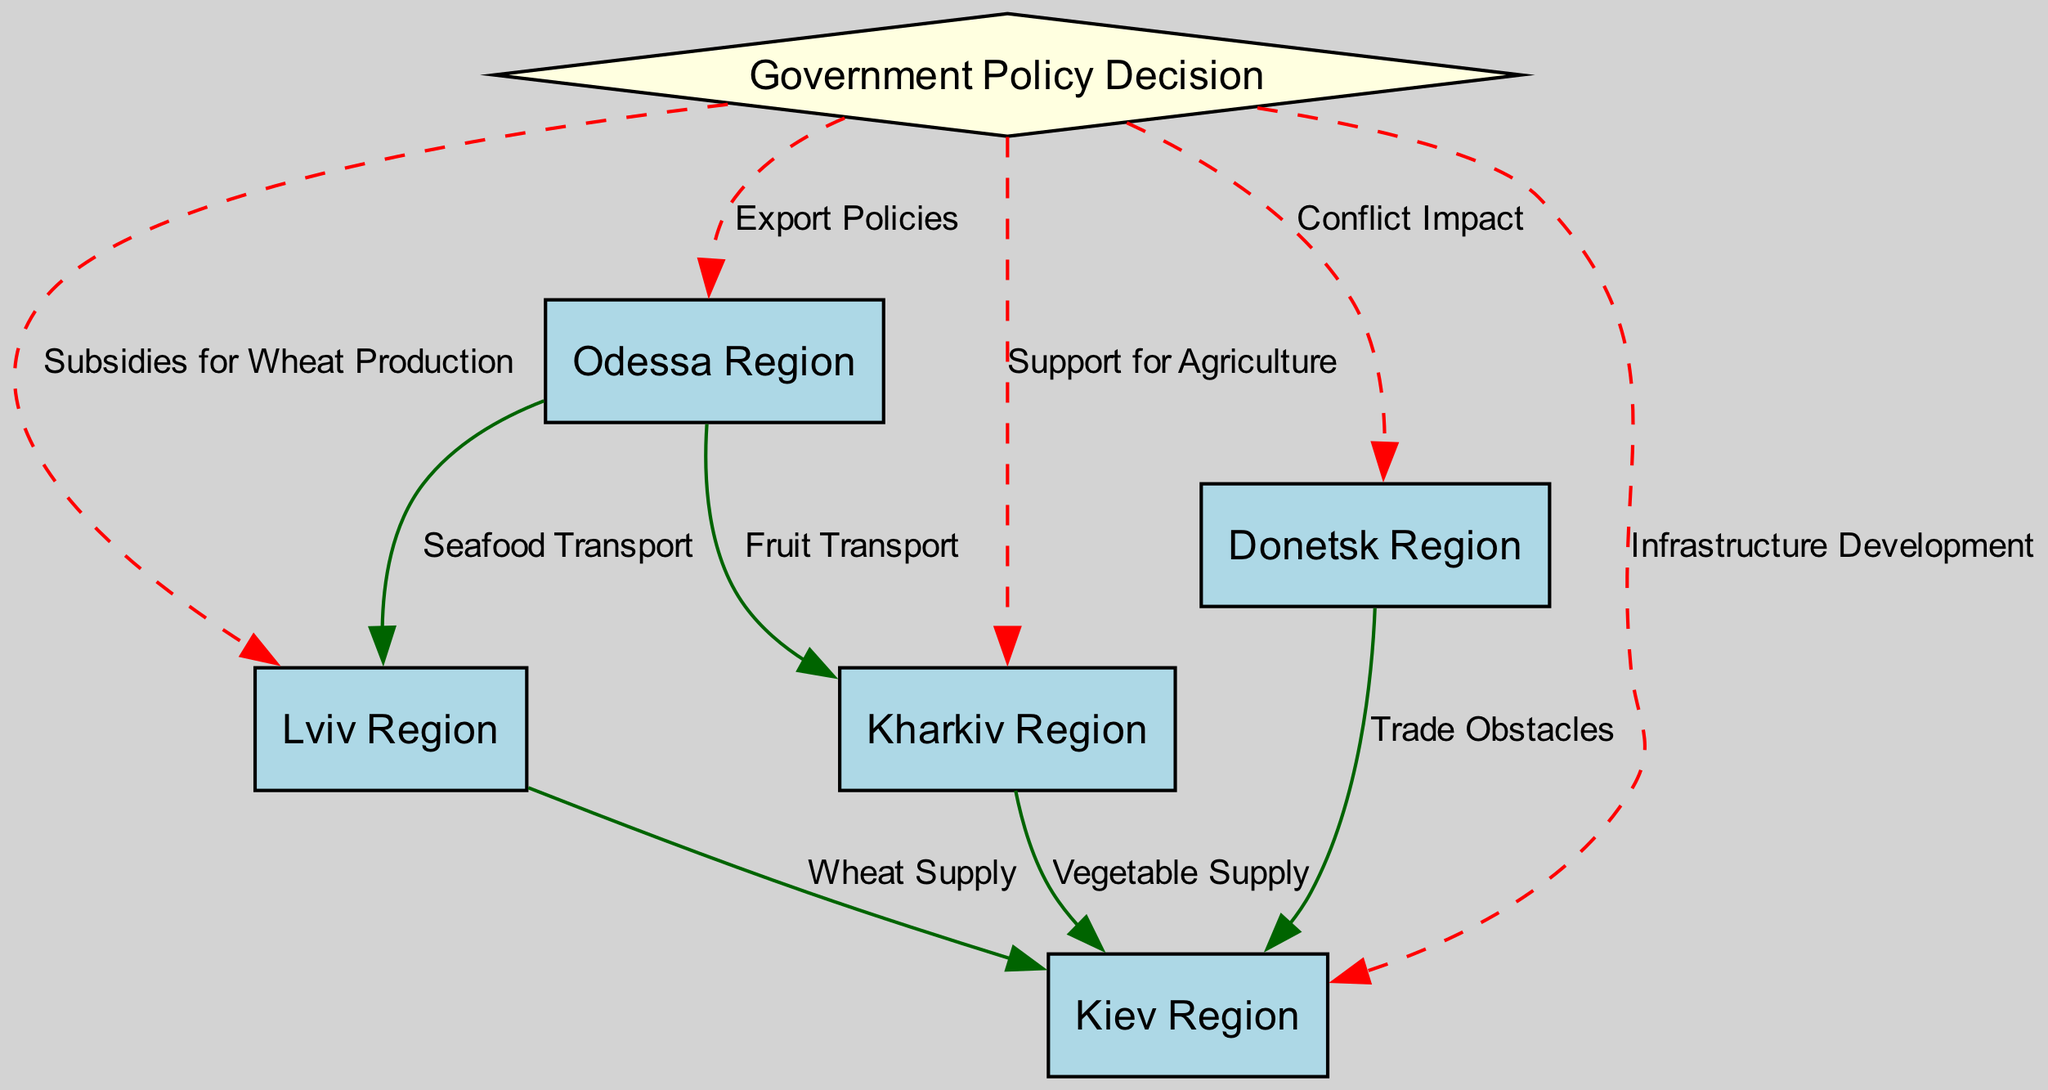What is the source of support for the Kharkiv Region in the diagram? The diagram indicates that the Kharkiv Region receives support through a direct policy labeled "Support for Agriculture," stemming from the Government Policy Decision node.
Answer: Support for Agriculture How many regions are directly linked to the Government Policy Decision? By analyzing the diagram, we observe that there are five edges leading from the Government Policy Decision to different regions (Lviv, Kiev, Odessa, Kharkiv, and Donetsk), thus confirming that five regions are directly linked.
Answer: 5 What type of transport is associated with the connection between Odessa and Lviv? The edge connecting Odessa to Lviv is labeled "Seafood Transport," indicating the specific type of transport involved in this relationship.
Answer: Seafood Transport Which region experiences trade obstacles affecting its supply routes? The diagram shows that the Donetsk Region faces trade obstacles as indicated by the edge labeled "Trade Obstacles" going to the Kiev Region, which influences its food supply dynamics.
Answer: Donetsk Region What relationship exists between the Kharkiv Region and Kiev in terms of food supply? The relationship is established through an edge labeled "Vegetable Supply," which indicates that Kharkiv region supplies vegetables to the Kiev region.
Answer: Vegetable Supply Which government decision primarily influences wheat production in relation to the Lviv Region? The Government Policy Decision impacts the Lviv Region specifically through the edge labeled "Subsidies for Wheat Production," indicating a financial influence aiming to boost wheat production.
Answer: Subsidies for Wheat Production List the two transportation links between Odessa and other regions. The diagram presents two transportation links: "Seafood Transport" from Odessa to Lviv and "Fruit Transport" from Odessa to Kharkiv, illustrating the flow of goods involved.
Answer: Seafood Transport and Fruit Transport In which direction does the conflict impact affect the supply routes according to the diagram? According to the diagram, the conflict impact originating from the Donetsk Region affects the supply routes towards the Kiev Region, showing a directional influence of political instability.
Answer: Kiev Region Which political decision relates to infrastructure in Kiev? The infrastructure development in the Kiev Region is directly linked to the Government Policy Decision, as indicated by the edge labeled with this explicit relationship.
Answer: Infrastructure Development 